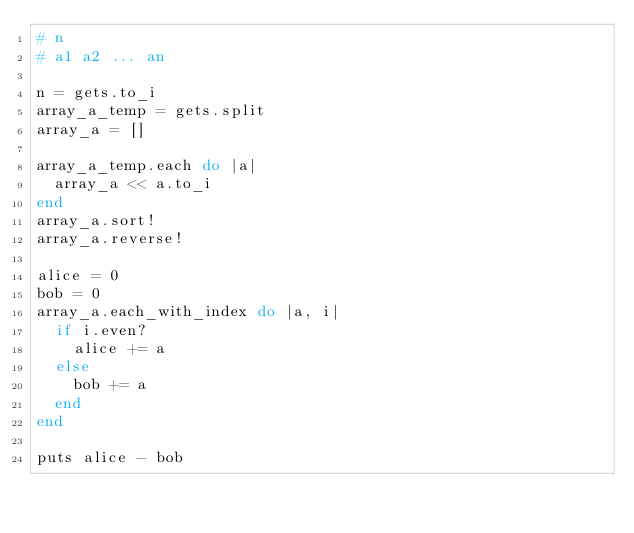Convert code to text. <code><loc_0><loc_0><loc_500><loc_500><_Ruby_># n
# a1 a2 ... an

n = gets.to_i
array_a_temp = gets.split
array_a = []

array_a_temp.each do |a|
  array_a << a.to_i
end
array_a.sort!
array_a.reverse!

alice = 0
bob = 0
array_a.each_with_index do |a, i|
  if i.even?
    alice += a
  else
    bob += a
  end
end

puts alice - bob

</code> 